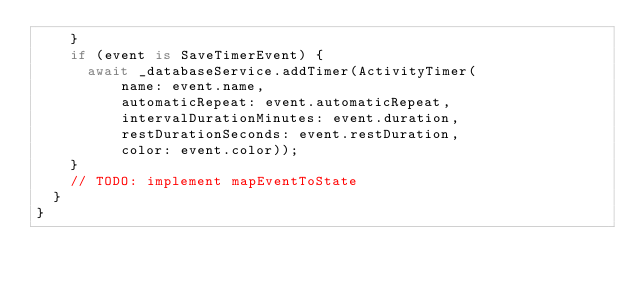Convert code to text. <code><loc_0><loc_0><loc_500><loc_500><_Dart_>    }
    if (event is SaveTimerEvent) {
      await _databaseService.addTimer(ActivityTimer(
          name: event.name,
          automaticRepeat: event.automaticRepeat,
          intervalDurationMinutes: event.duration,
          restDurationSeconds: event.restDuration,
          color: event.color));
    }
    // TODO: implement mapEventToState
  }
}
</code> 